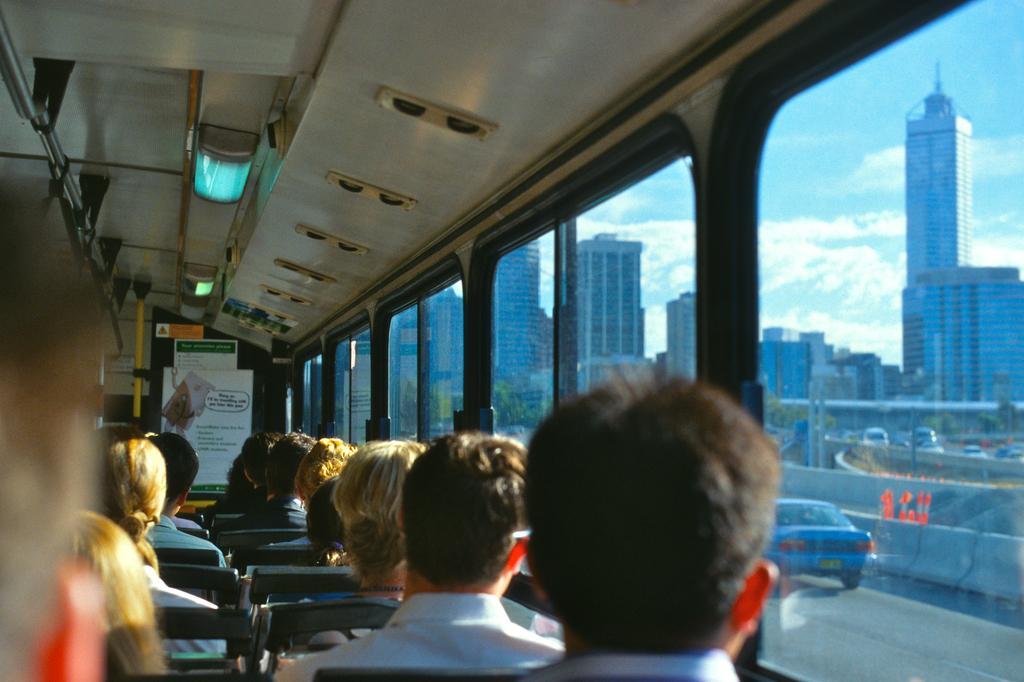Can you describe this image briefly? This is the picture of a vehicle in which we can see some people sitting on the seats and in the bus there is a light, glass windows from which we can see some buildings, trees and some cars. 